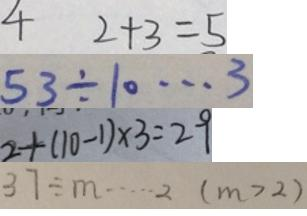<formula> <loc_0><loc_0><loc_500><loc_500>4 2 + 3 = 5 
 5 3 \div 1 0 \cdots 3 
 2 + ( 1 0 - 1 ) \times 3 = 2 9 
 3 . 7 \div m \cdots 2 ( m > 2 )</formula> 